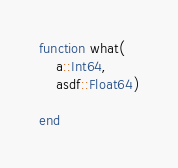<code> <loc_0><loc_0><loc_500><loc_500><_Julia_>

function what(
    a::Int64,
    asdf::Float64)

end
</code> 